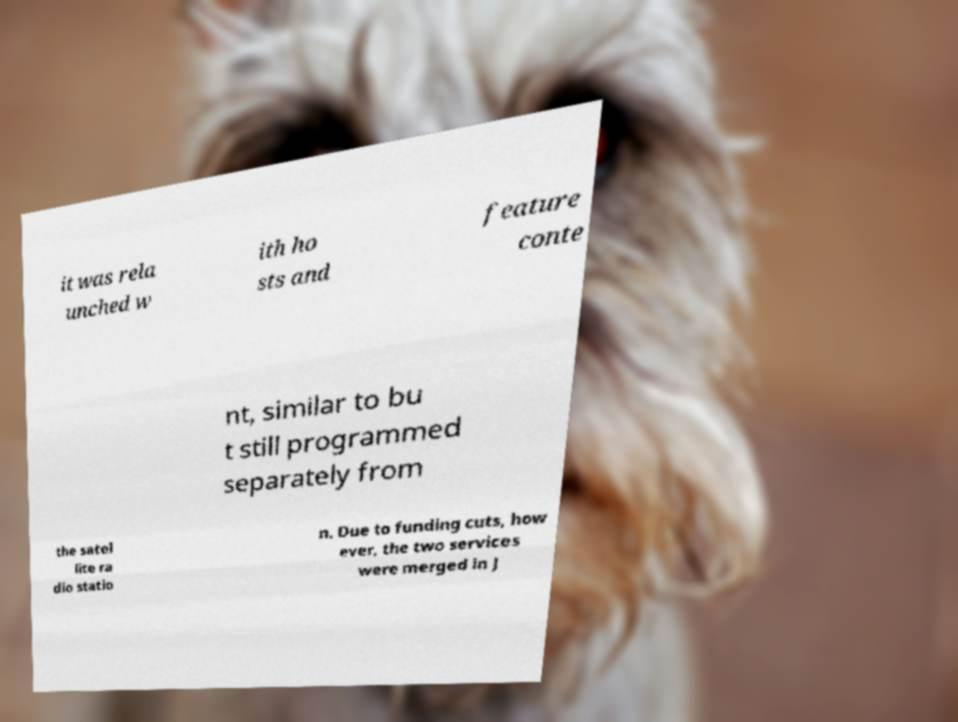Please read and relay the text visible in this image. What does it say? it was rela unched w ith ho sts and feature conte nt, similar to bu t still programmed separately from the satel lite ra dio statio n. Due to funding cuts, how ever, the two services were merged in J 